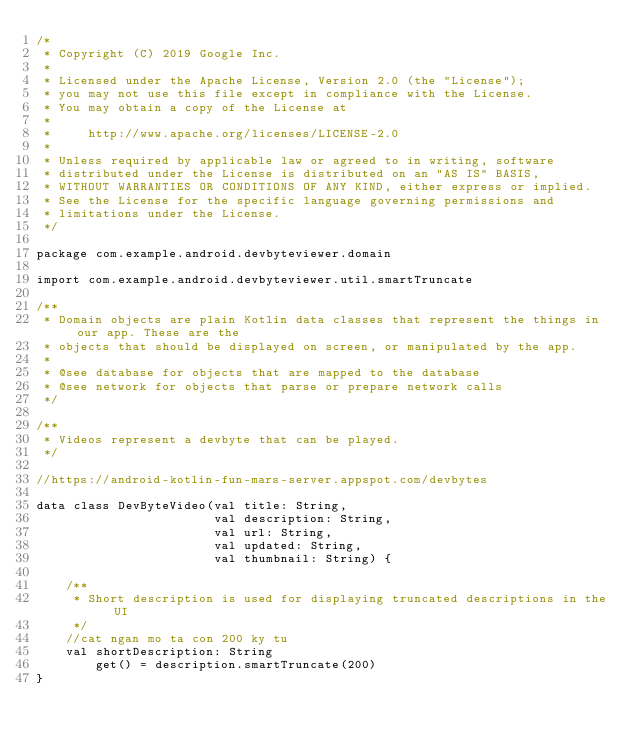Convert code to text. <code><loc_0><loc_0><loc_500><loc_500><_Kotlin_>/*
 * Copyright (C) 2019 Google Inc.
 *
 * Licensed under the Apache License, Version 2.0 (the "License");
 * you may not use this file except in compliance with the License.
 * You may obtain a copy of the License at
 *
 *     http://www.apache.org/licenses/LICENSE-2.0
 *
 * Unless required by applicable law or agreed to in writing, software
 * distributed under the License is distributed on an "AS IS" BASIS,
 * WITHOUT WARRANTIES OR CONDITIONS OF ANY KIND, either express or implied.
 * See the License for the specific language governing permissions and
 * limitations under the License.
 */

package com.example.android.devbyteviewer.domain

import com.example.android.devbyteviewer.util.smartTruncate

/**
 * Domain objects are plain Kotlin data classes that represent the things in our app. These are the
 * objects that should be displayed on screen, or manipulated by the app.
 *
 * @see database for objects that are mapped to the database
 * @see network for objects that parse or prepare network calls
 */

/**
 * Videos represent a devbyte that can be played.
 */

//https://android-kotlin-fun-mars-server.appspot.com/devbytes

data class DevByteVideo(val title: String,
                        val description: String,
                        val url: String,
                        val updated: String,
                        val thumbnail: String) {

    /**
     * Short description is used for displaying truncated descriptions in the UI
     */
    //cat ngan mo ta con 200 ky tu
    val shortDescription: String
        get() = description.smartTruncate(200)
}</code> 